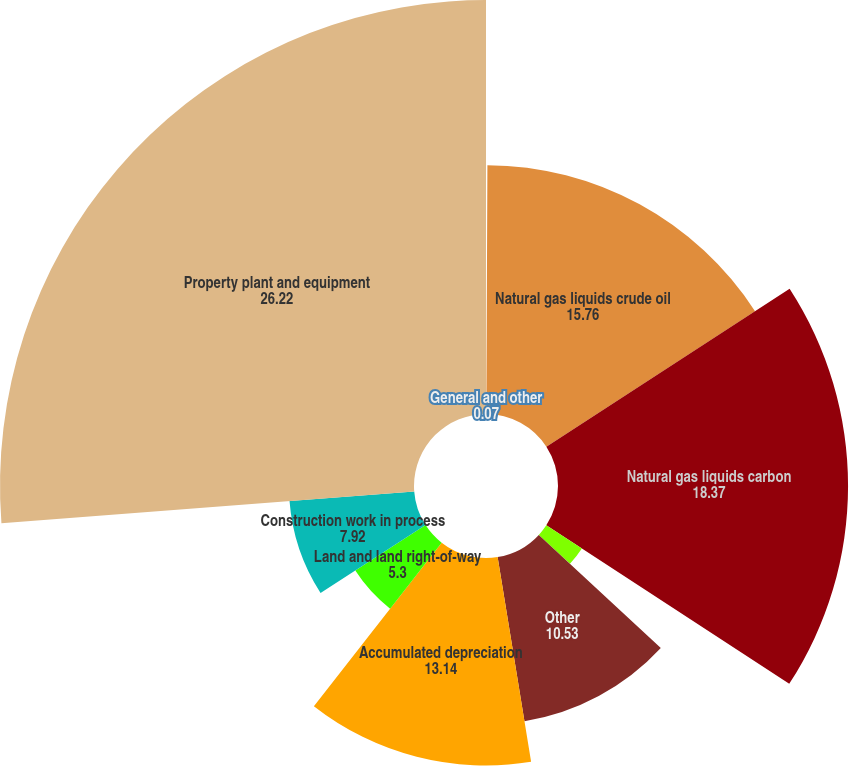Convert chart. <chart><loc_0><loc_0><loc_500><loc_500><pie_chart><fcel>General and other<fcel>Natural gas liquids crude oil<fcel>Natural gas liquids carbon<fcel>Natural gas liquids (including<fcel>Other<fcel>Accumulated depreciation<fcel>Land and land right-of-way<fcel>Construction work in process<fcel>Property plant and equipment<nl><fcel>0.07%<fcel>15.76%<fcel>18.37%<fcel>2.69%<fcel>10.53%<fcel>13.14%<fcel>5.3%<fcel>7.92%<fcel>26.22%<nl></chart> 